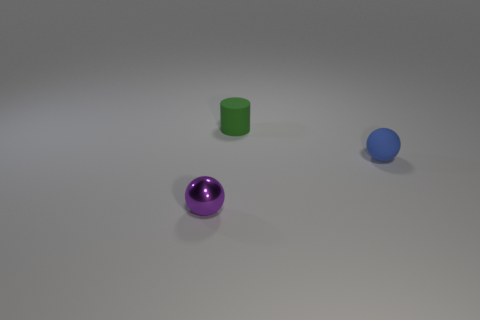Is there any indication of movement or life in this image? The image is still and there are no explicit indications of movement or life. The lack of animate objects or apparent motion supports the impression of a static visual, typically resembling a 3D rendered demonstration or a product display. 